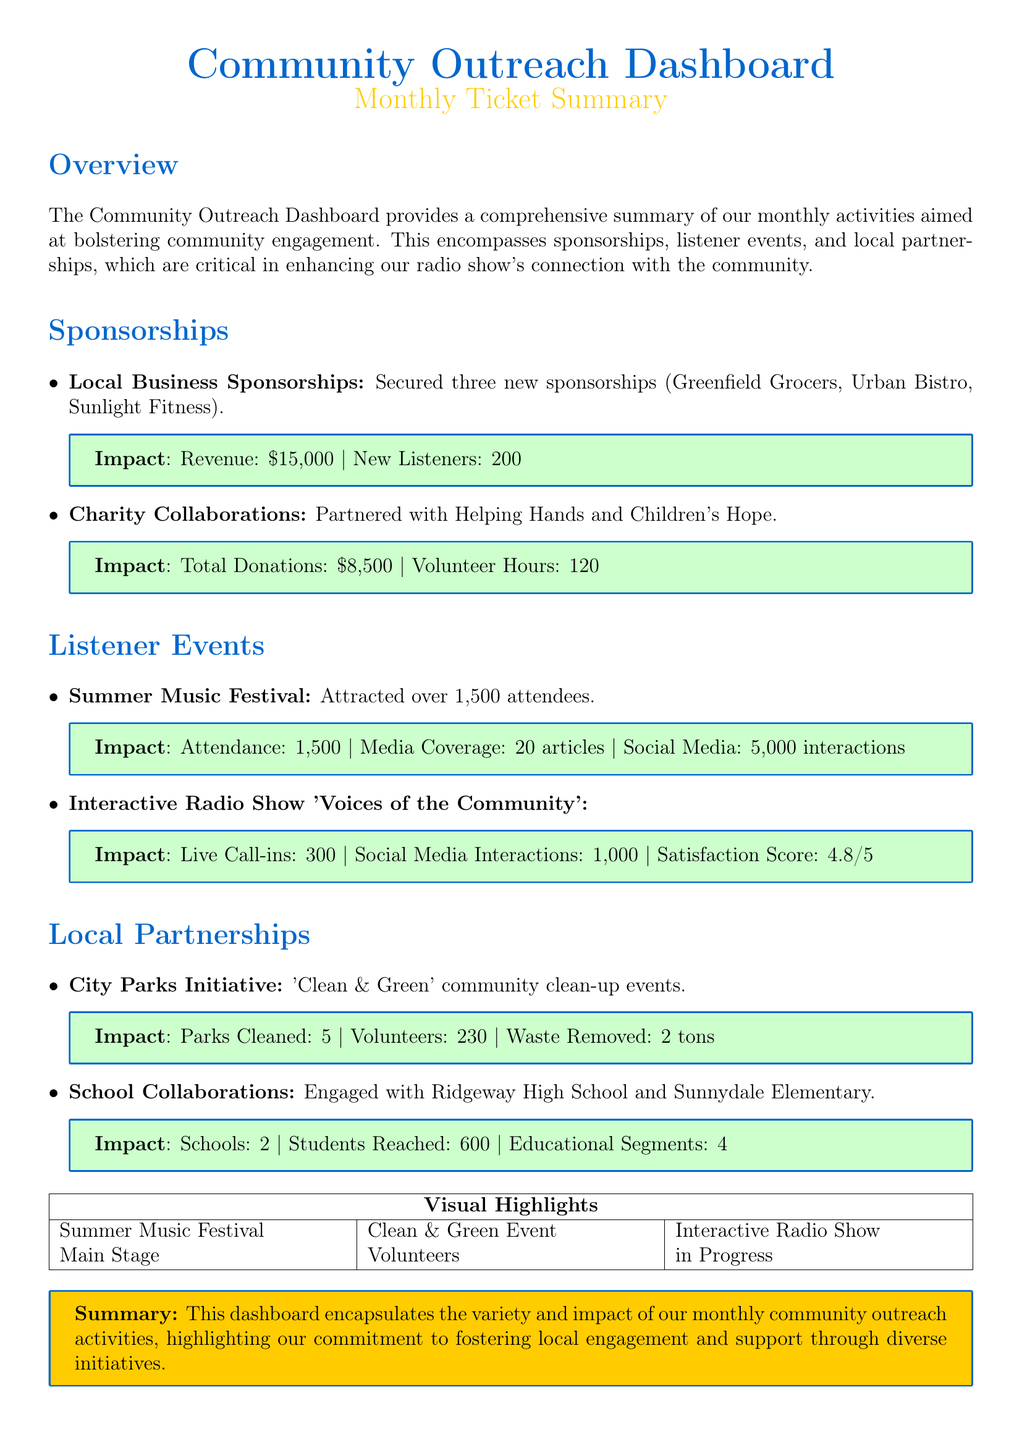What is the total revenue from local business sponsorships? The document states that the total revenue from local business sponsorships is $15,000.
Answer: $15,000 How many new listeners were gained from sponsorships? The document mentions that 200 new listeners were gained from the local business sponsorships.
Answer: 200 What was the attendance at the Summer Music Festival? The document indicates that the Summer Music Festival attracted over 1,500 attendees.
Answer: 1,500 How many volunteers participated in the City Parks Initiative? The document states that 230 volunteers participated in the 'Clean & Green' community clean-up events.
Answer: 230 What is the satisfaction score for the Interactive Radio Show? The document mentions a satisfaction score of 4.8 out of 5 for the Interactive Radio Show.
Answer: 4.8/5 How many articles covered the Summer Music Festival? The document indicates that there were 20 articles covering the Summer Music Festival.
Answer: 20 Which charity organization partnered for donations? The document lists Helping Hands and Children's Hope as the partnered charity organizations.
Answer: Helping Hands and Children's Hope What was the total amount of donations received from charity collaborations? The document states that total donations received were $8,500 from charity collaborations.
Answer: $8,500 How many educational segments were provided in the school collaborations? The document mentions that 4 educational segments were provided with school collaborations.
Answer: 4 